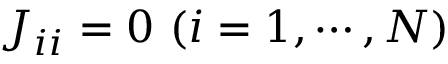<formula> <loc_0><loc_0><loc_500><loc_500>J _ { i i } = 0 ( i = 1 , \cdots , N )</formula> 